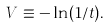<formula> <loc_0><loc_0><loc_500><loc_500>V \equiv - \ln ( 1 / t ) .</formula> 